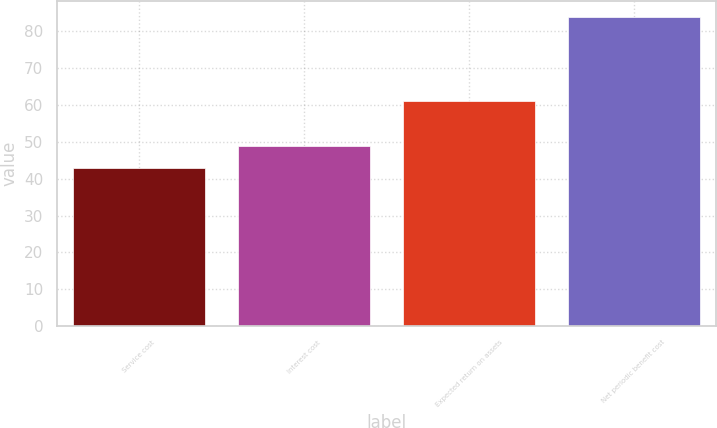<chart> <loc_0><loc_0><loc_500><loc_500><bar_chart><fcel>Service cost<fcel>Interest cost<fcel>Expected return on assets<fcel>Net periodic benefit cost<nl><fcel>43<fcel>49<fcel>61<fcel>84<nl></chart> 